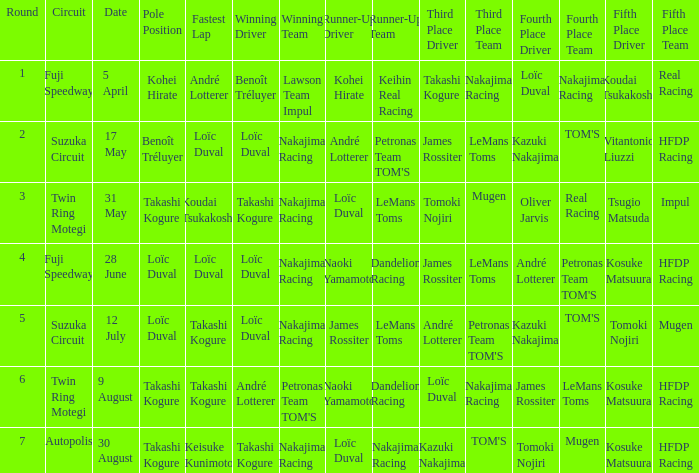What was the earlier round where Takashi Kogure got the fastest lap? 5.0. 